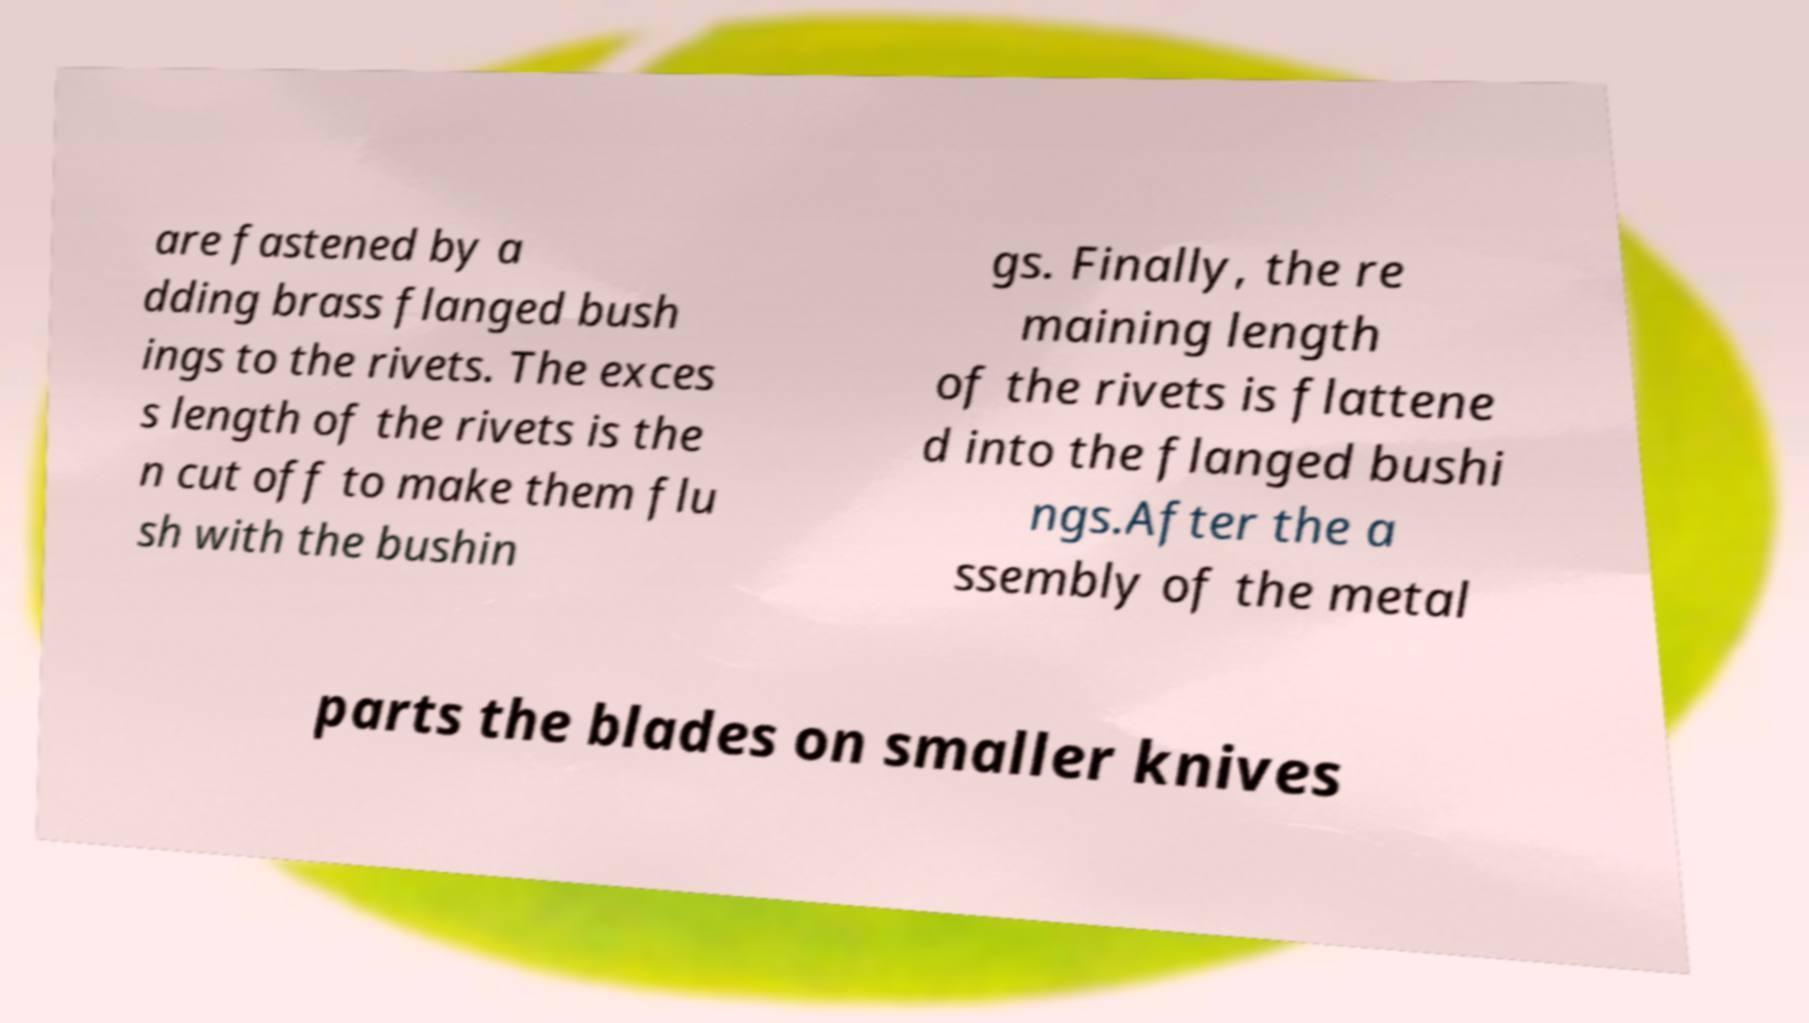Could you extract and type out the text from this image? are fastened by a dding brass flanged bush ings to the rivets. The exces s length of the rivets is the n cut off to make them flu sh with the bushin gs. Finally, the re maining length of the rivets is flattene d into the flanged bushi ngs.After the a ssembly of the metal parts the blades on smaller knives 